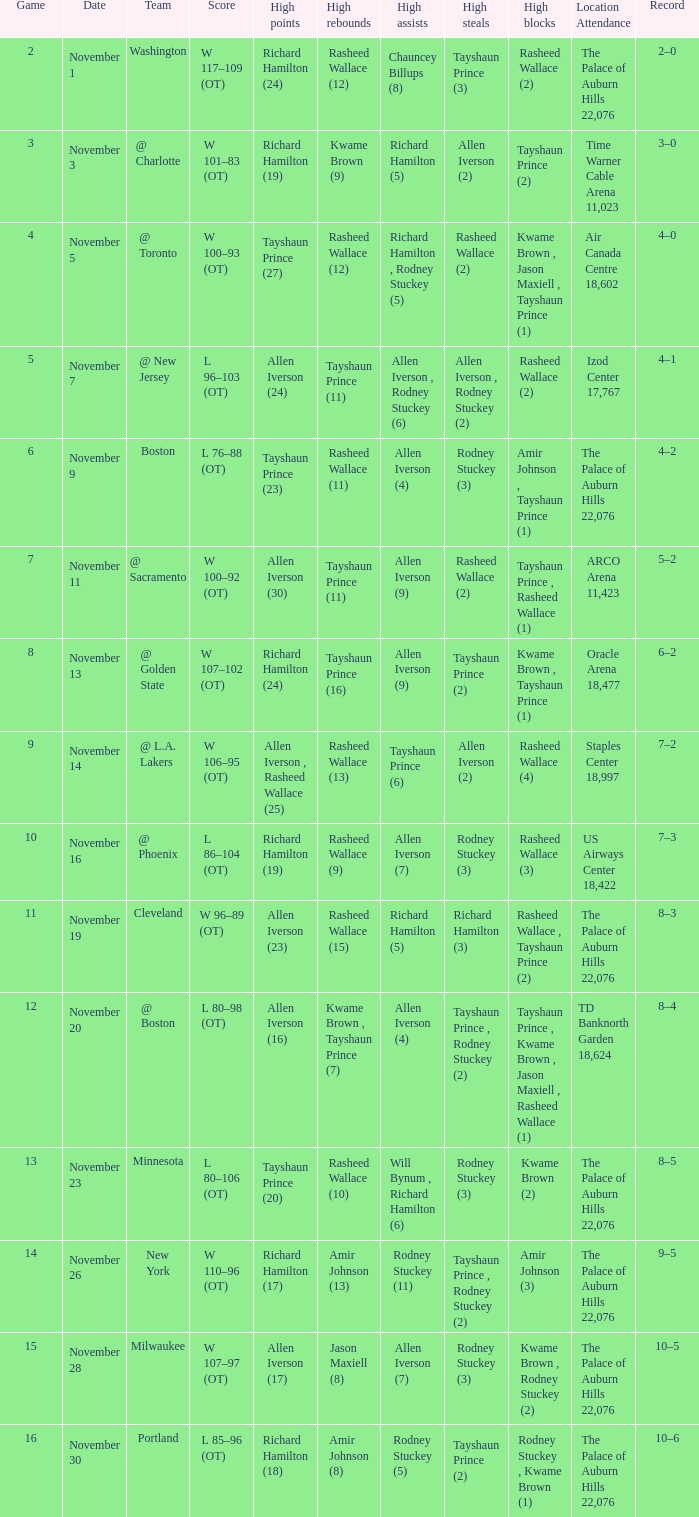What is the average Game, when Team is "Milwaukee"? 15.0. 